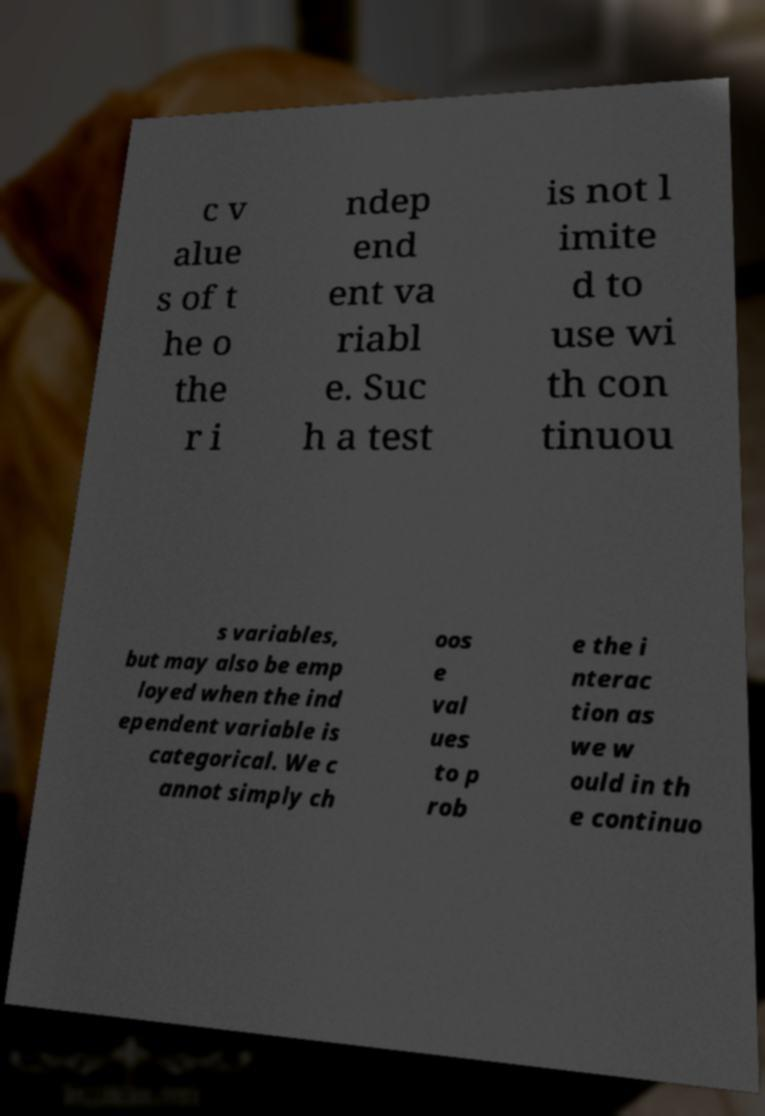I need the written content from this picture converted into text. Can you do that? c v alue s of t he o the r i ndep end ent va riabl e. Suc h a test is not l imite d to use wi th con tinuou s variables, but may also be emp loyed when the ind ependent variable is categorical. We c annot simply ch oos e val ues to p rob e the i nterac tion as we w ould in th e continuo 